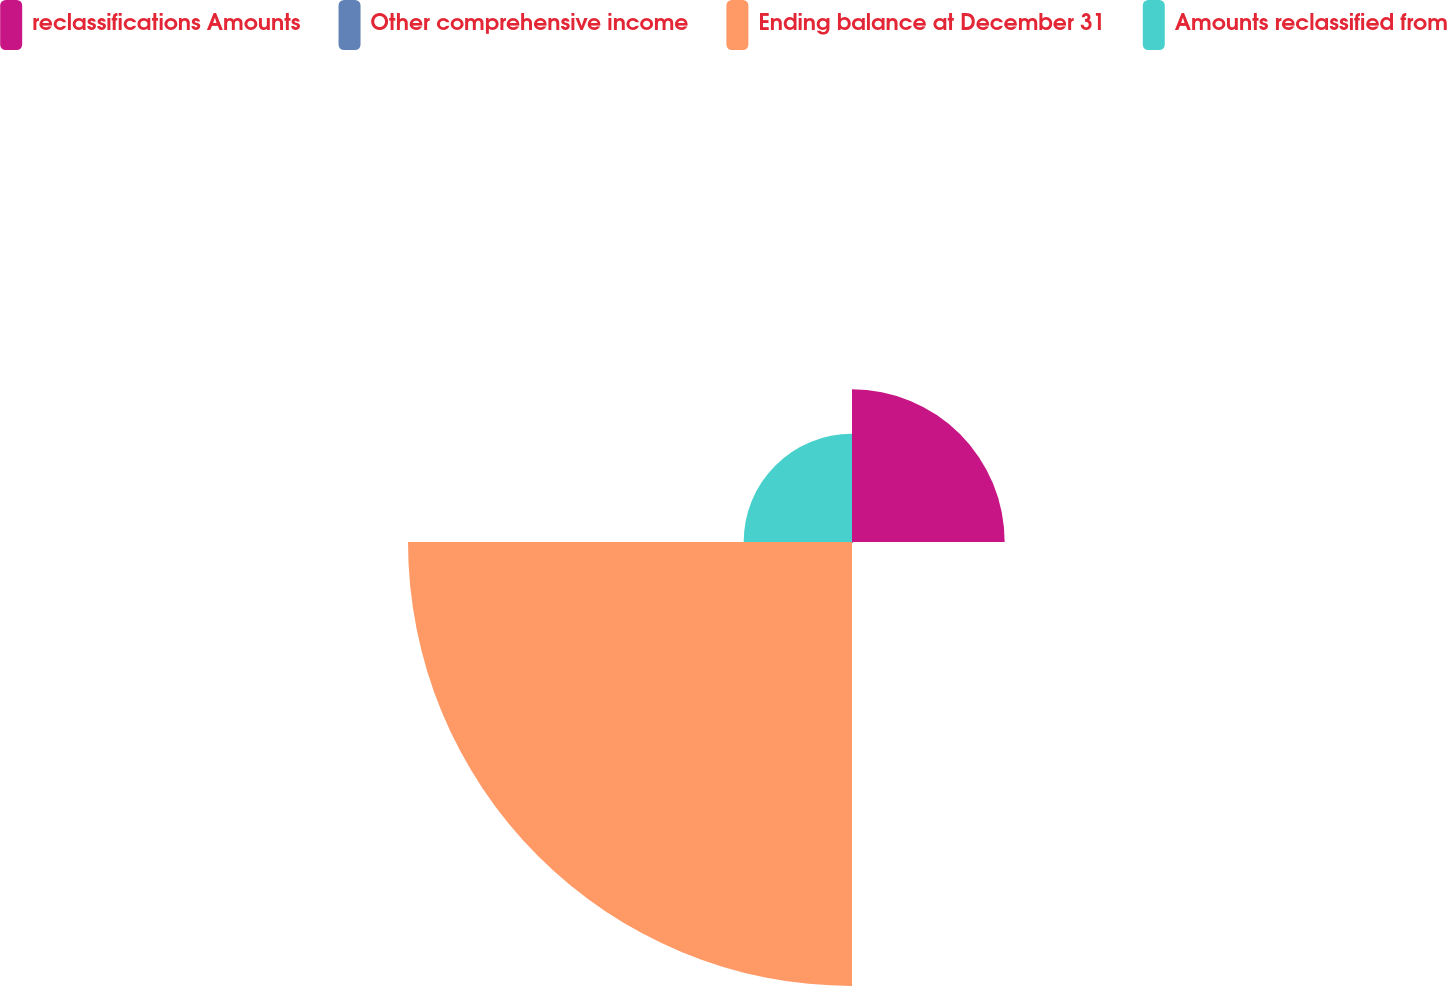<chart> <loc_0><loc_0><loc_500><loc_500><pie_chart><fcel>reclassifications Amounts<fcel>Other comprehensive income<fcel>Ending balance at December 31<fcel>Amounts reclassified from<nl><fcel>21.62%<fcel>0.16%<fcel>62.88%<fcel>15.34%<nl></chart> 